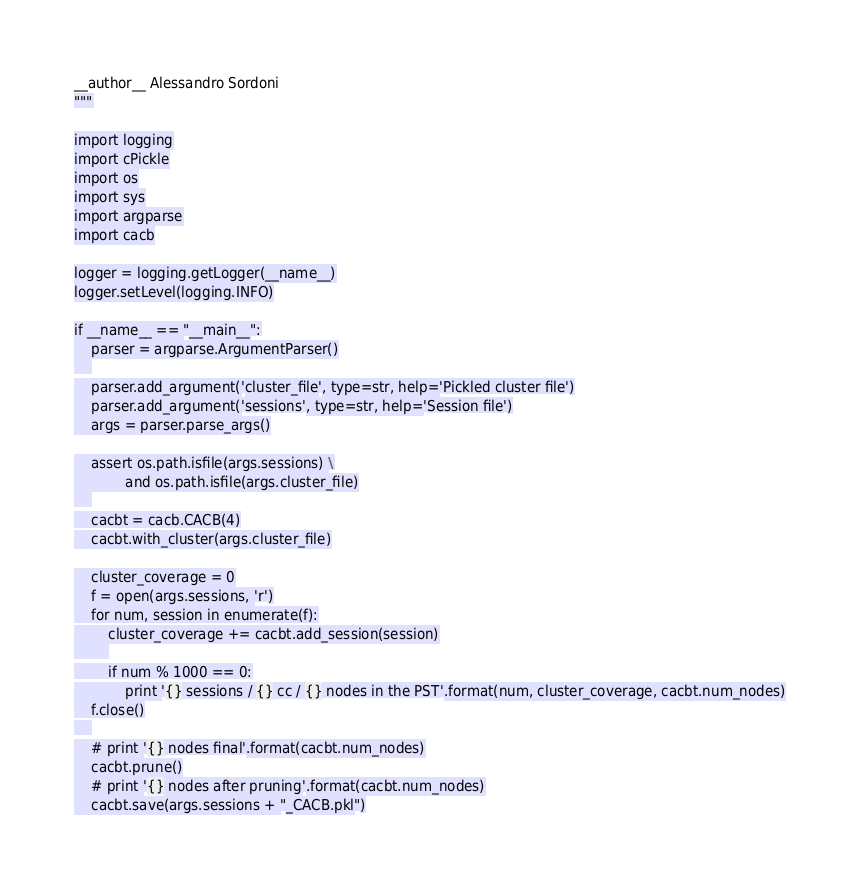<code> <loc_0><loc_0><loc_500><loc_500><_Python_>__author__ Alessandro Sordoni
"""

import logging
import cPickle
import os
import sys
import argparse
import cacb

logger = logging.getLogger(__name__)
logger.setLevel(logging.INFO)

if __name__ == "__main__":
    parser = argparse.ArgumentParser()
    
    parser.add_argument('cluster_file', type=str, help='Pickled cluster file')
    parser.add_argument('sessions', type=str, help='Session file')
    args = parser.parse_args()

    assert os.path.isfile(args.sessions) \
            and os.path.isfile(args.cluster_file)
    
    cacbt = cacb.CACB(4)
    cacbt.with_cluster(args.cluster_file)

    cluster_coverage = 0
    f = open(args.sessions, 'r')
    for num, session in enumerate(f):
        cluster_coverage += cacbt.add_session(session)
        
        if num % 1000 == 0:
            print '{} sessions / {} cc / {} nodes in the PST'.format(num, cluster_coverage, cacbt.num_nodes)
    f.close()
    
    # print '{} nodes final'.format(cacbt.num_nodes)
    cacbt.prune()
    # print '{} nodes after pruning'.format(cacbt.num_nodes)
    cacbt.save(args.sessions + "_CACB.pkl")
</code> 